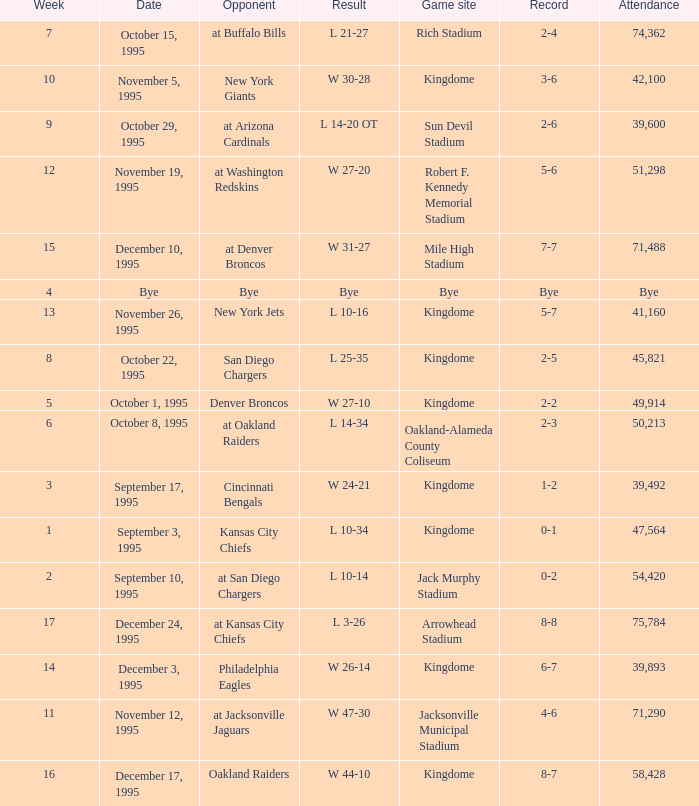Who was the opponent when the Seattle Seahawks had a record of 8-7? Oakland Raiders. 